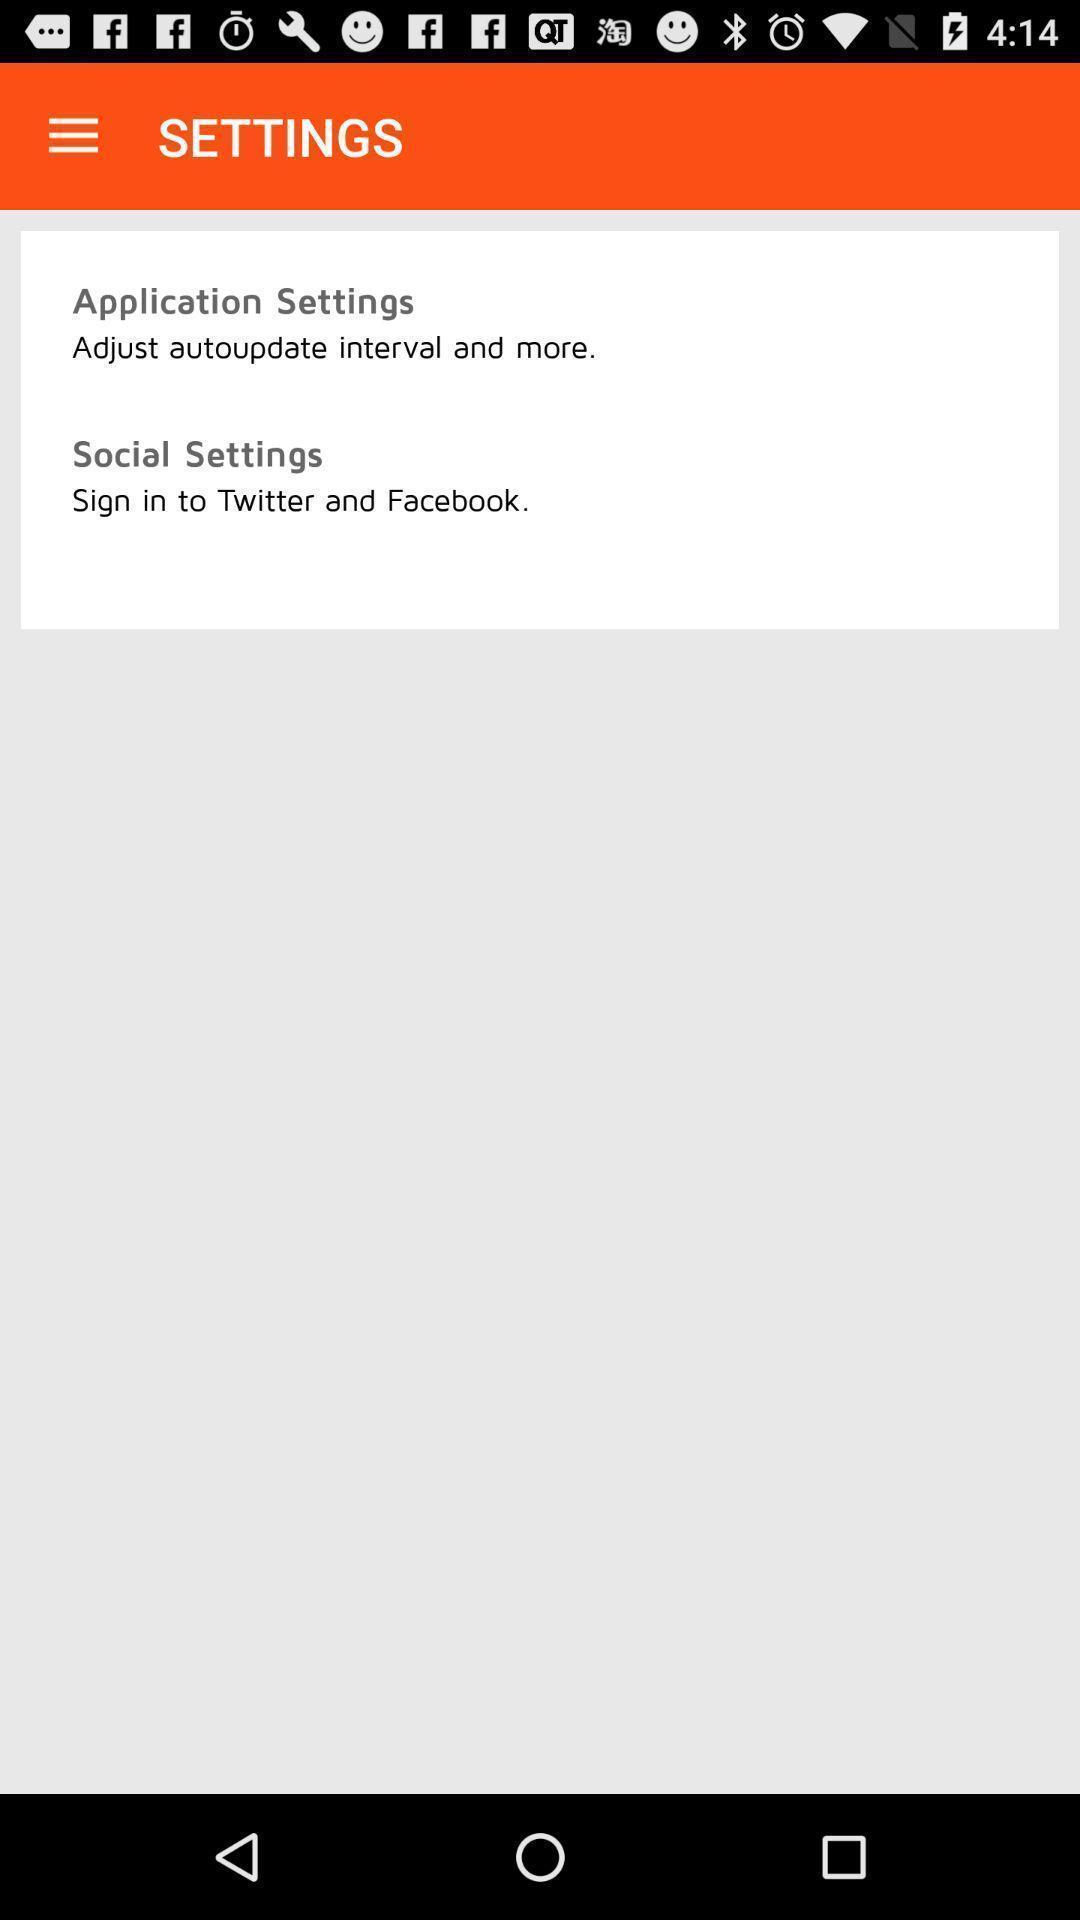Explain what's happening in this screen capture. Screen displaying the settings page. 